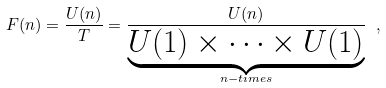<formula> <loc_0><loc_0><loc_500><loc_500>F ( n ) = \frac { U ( n ) } { T } = \frac { U ( n ) } { \underbrace { U ( 1 ) \times \cdots \times U ( 1 ) } _ { n - t i m e s } } \ ,</formula> 